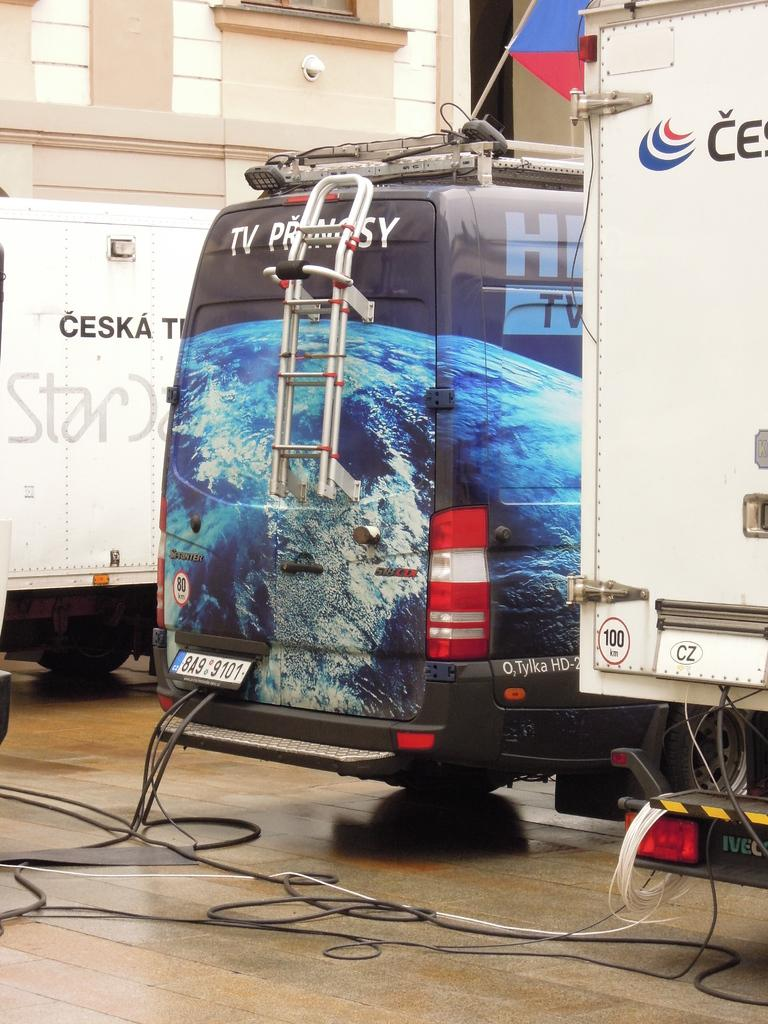What is located on the platform in the image? There are vehicles on a platform in the image. What else can be seen in the image besides the vehicles? There are wires visible in the image. What is visible in the background of the image? There is a building and a flag with a rod in the background of the image. What type of soap is being used to clean the vehicles in the image? There is no soap or cleaning activity present in the image; it only shows vehicles on a platform, wires, a building, and a flag with a rod in the background. 